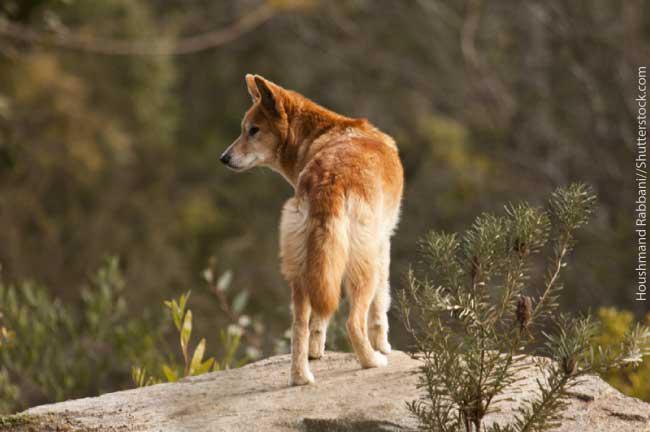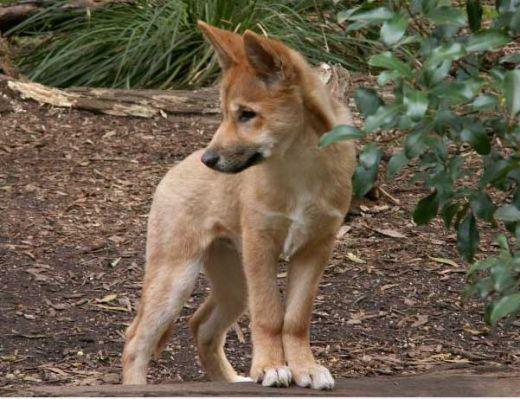The first image is the image on the left, the second image is the image on the right. Assess this claim about the two images: "There are exactly two animals in the image on the right.". Correct or not? Answer yes or no. No. 